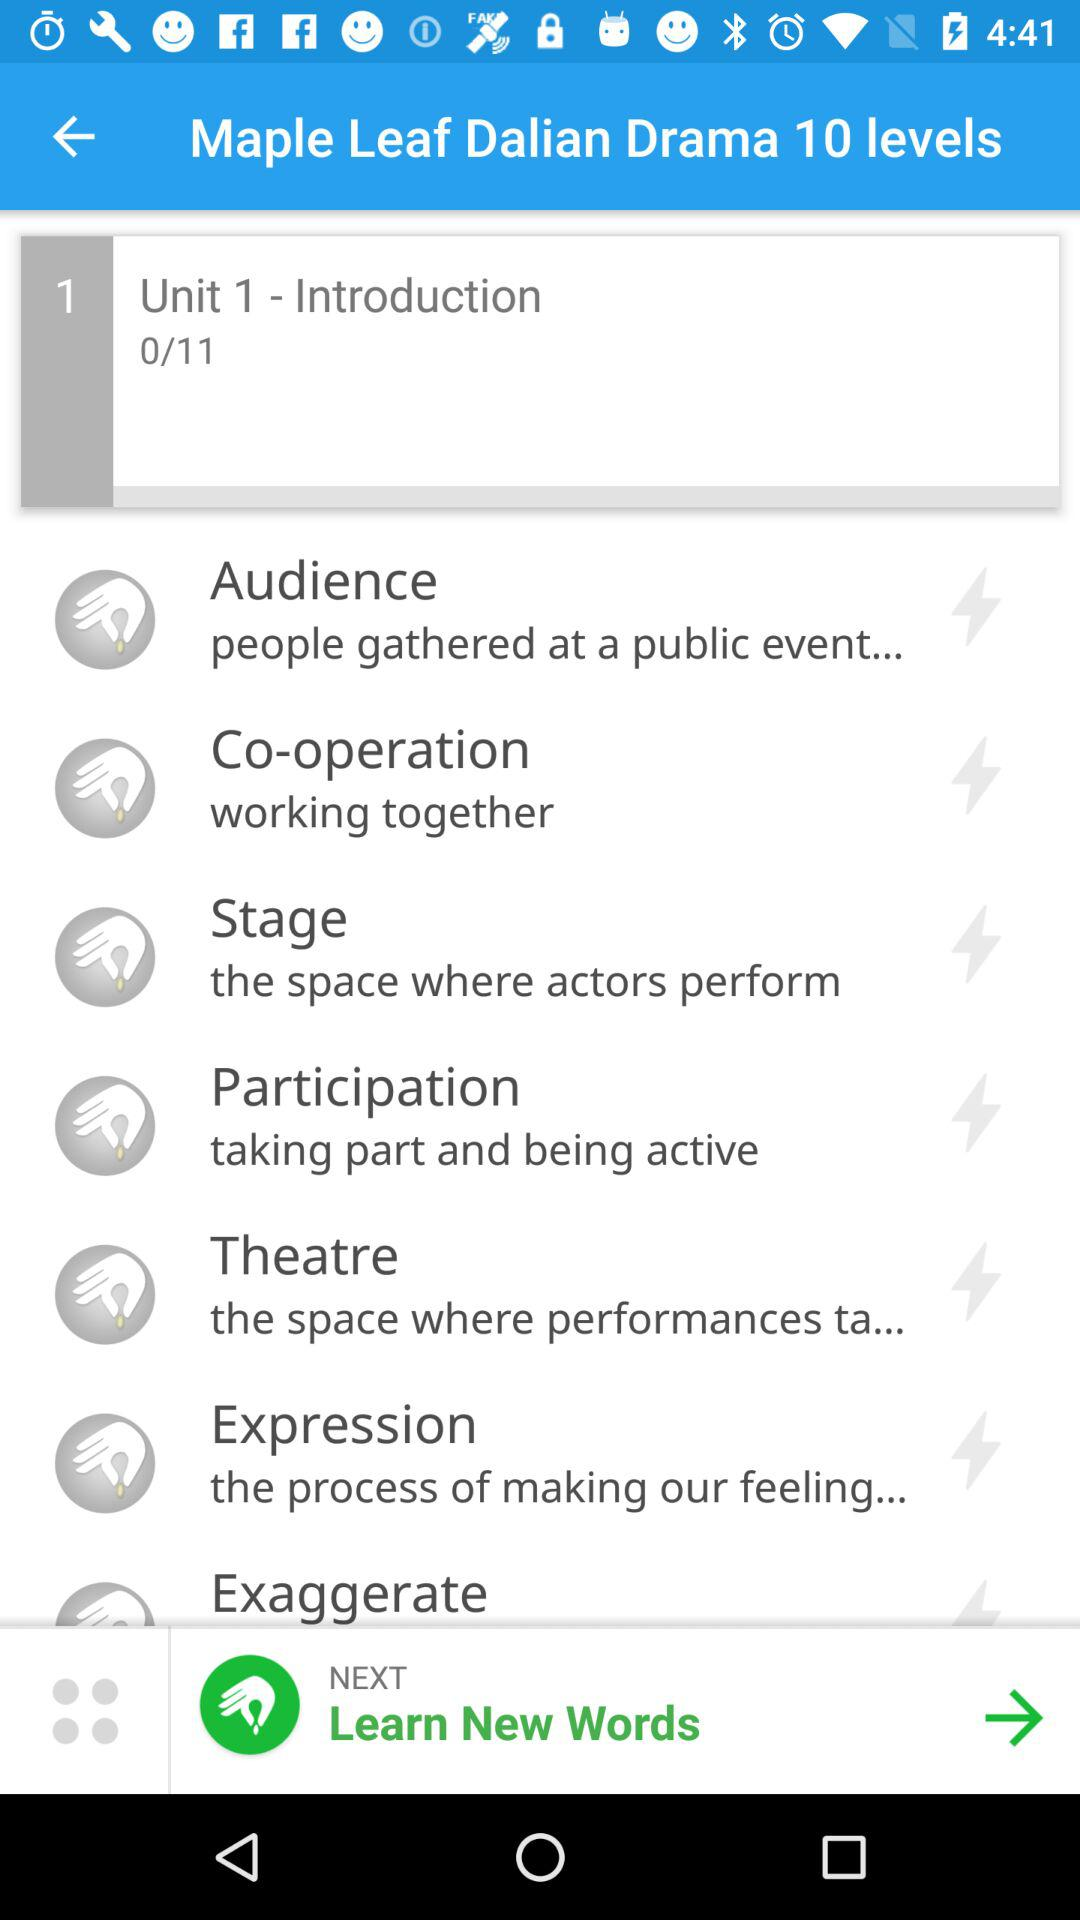What are the total parts of unit 1? The total parts of unit 1 is 11. 